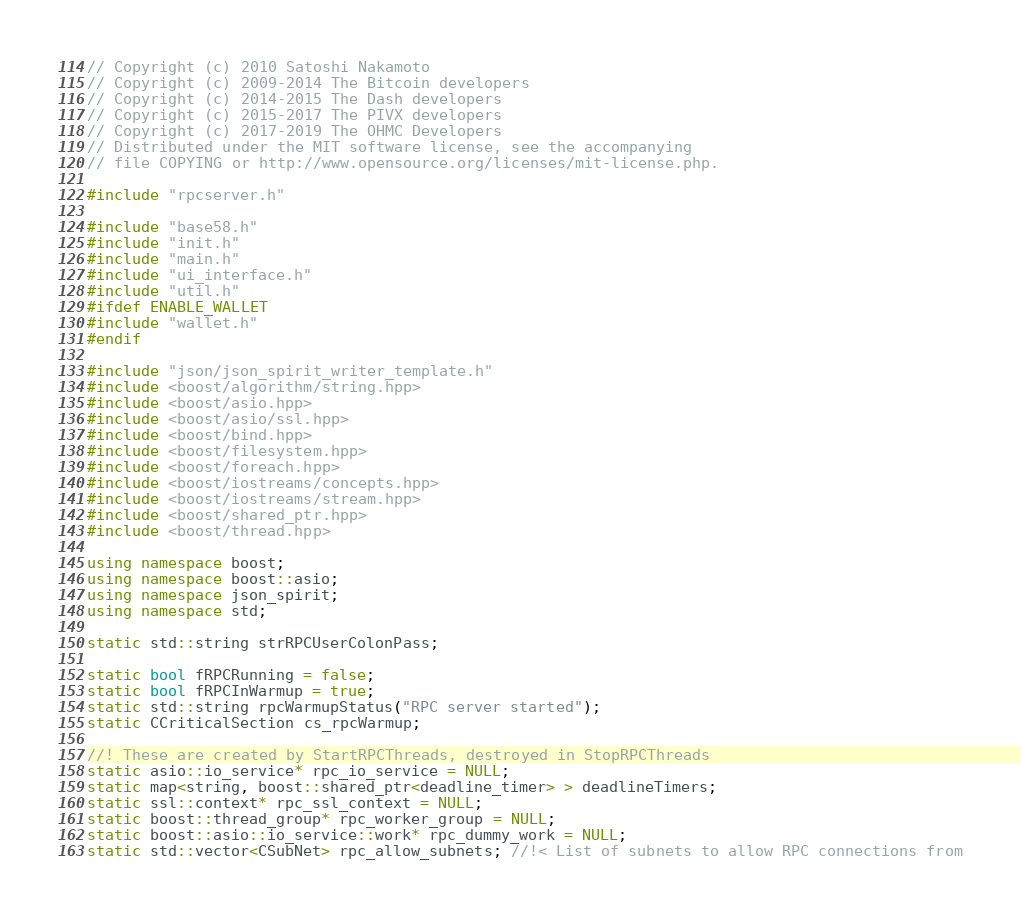Convert code to text. <code><loc_0><loc_0><loc_500><loc_500><_C++_>// Copyright (c) 2010 Satoshi Nakamoto
// Copyright (c) 2009-2014 The Bitcoin developers
// Copyright (c) 2014-2015 The Dash developers
// Copyright (c) 2015-2017 The PIVX developers
// Copyright (c) 2017-2019 The OHMC Developers 
// Distributed under the MIT software license, see the accompanying
// file COPYING or http://www.opensource.org/licenses/mit-license.php.

#include "rpcserver.h"

#include "base58.h"
#include "init.h"
#include "main.h"
#include "ui_interface.h"
#include "util.h"
#ifdef ENABLE_WALLET
#include "wallet.h"
#endif

#include "json/json_spirit_writer_template.h"
#include <boost/algorithm/string.hpp>
#include <boost/asio.hpp>
#include <boost/asio/ssl.hpp>
#include <boost/bind.hpp>
#include <boost/filesystem.hpp>
#include <boost/foreach.hpp>
#include <boost/iostreams/concepts.hpp>
#include <boost/iostreams/stream.hpp>
#include <boost/shared_ptr.hpp>
#include <boost/thread.hpp>

using namespace boost;
using namespace boost::asio;
using namespace json_spirit;
using namespace std;

static std::string strRPCUserColonPass;

static bool fRPCRunning = false;
static bool fRPCInWarmup = true;
static std::string rpcWarmupStatus("RPC server started");
static CCriticalSection cs_rpcWarmup;

//! These are created by StartRPCThreads, destroyed in StopRPCThreads
static asio::io_service* rpc_io_service = NULL;
static map<string, boost::shared_ptr<deadline_timer> > deadlineTimers;
static ssl::context* rpc_ssl_context = NULL;
static boost::thread_group* rpc_worker_group = NULL;
static boost::asio::io_service::work* rpc_dummy_work = NULL;
static std::vector<CSubNet> rpc_allow_subnets; //!< List of subnets to allow RPC connections from</code> 